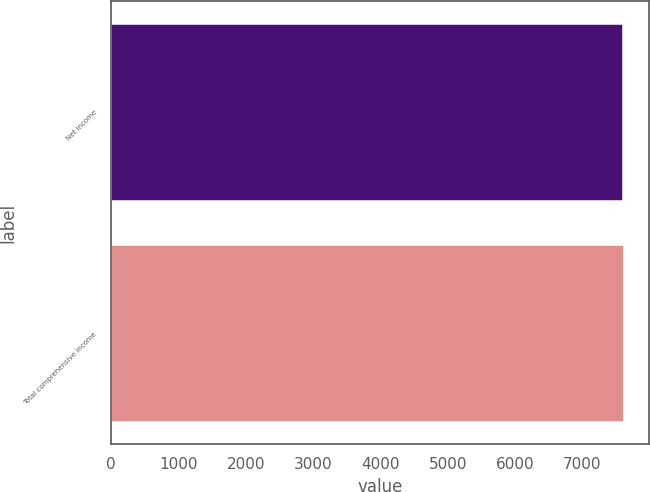<chart> <loc_0><loc_0><loc_500><loc_500><bar_chart><fcel>Net income<fcel>Total comprehensive income<nl><fcel>7610<fcel>7610.1<nl></chart> 